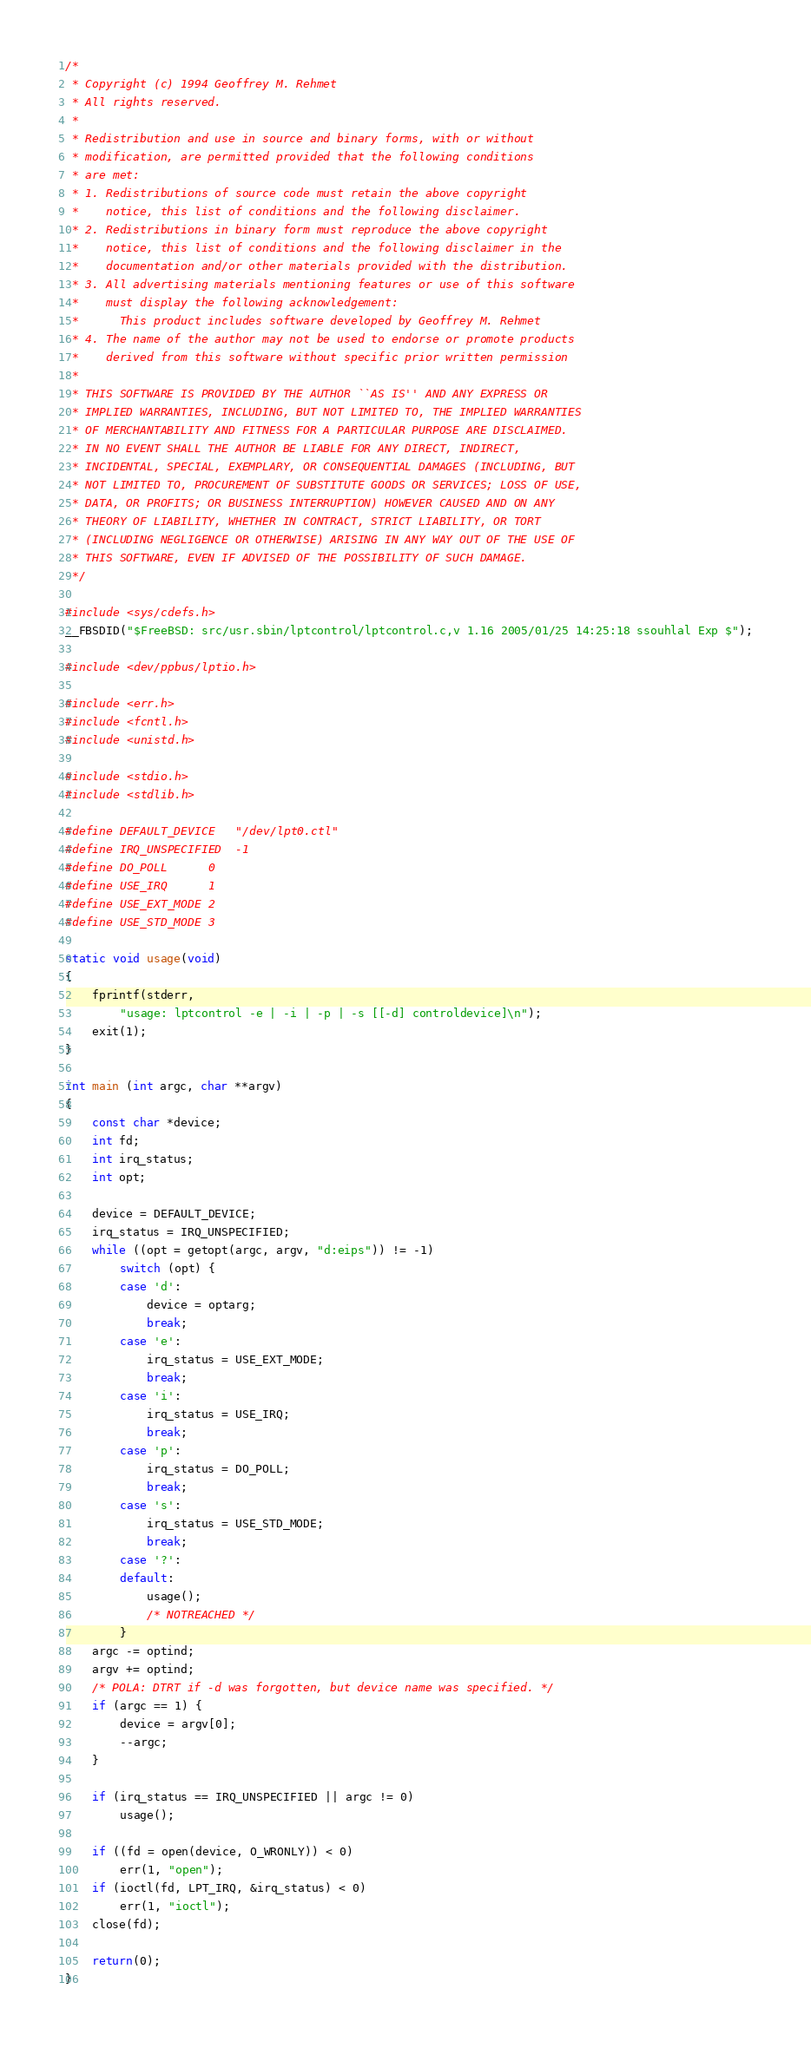<code> <loc_0><loc_0><loc_500><loc_500><_C_>/*
 * Copyright (c) 1994 Geoffrey M. Rehmet
 * All rights reserved.
 *
 * Redistribution and use in source and binary forms, with or without
 * modification, are permitted provided that the following conditions
 * are met:
 * 1. Redistributions of source code must retain the above copyright
 *    notice, this list of conditions and the following disclaimer.
 * 2. Redistributions in binary form must reproduce the above copyright
 *    notice, this list of conditions and the following disclaimer in the
 *    documentation and/or other materials provided with the distribution.
 * 3. All advertising materials mentioning features or use of this software
 *    must display the following acknowledgement:
 *      This product includes software developed by Geoffrey M. Rehmet
 * 4. The name of the author may not be used to endorse or promote products
 *    derived from this software without specific prior written permission
 *
 * THIS SOFTWARE IS PROVIDED BY THE AUTHOR ``AS IS'' AND ANY EXPRESS OR
 * IMPLIED WARRANTIES, INCLUDING, BUT NOT LIMITED TO, THE IMPLIED WARRANTIES
 * OF MERCHANTABILITY AND FITNESS FOR A PARTICULAR PURPOSE ARE DISCLAIMED.
 * IN NO EVENT SHALL THE AUTHOR BE LIABLE FOR ANY DIRECT, INDIRECT,
 * INCIDENTAL, SPECIAL, EXEMPLARY, OR CONSEQUENTIAL DAMAGES (INCLUDING, BUT
 * NOT LIMITED TO, PROCUREMENT OF SUBSTITUTE GOODS OR SERVICES; LOSS OF USE,
 * DATA, OR PROFITS; OR BUSINESS INTERRUPTION) HOWEVER CAUSED AND ON ANY
 * THEORY OF LIABILITY, WHETHER IN CONTRACT, STRICT LIABILITY, OR TORT
 * (INCLUDING NEGLIGENCE OR OTHERWISE) ARISING IN ANY WAY OUT OF THE USE OF
 * THIS SOFTWARE, EVEN IF ADVISED OF THE POSSIBILITY OF SUCH DAMAGE.
 */

#include <sys/cdefs.h>
__FBSDID("$FreeBSD: src/usr.sbin/lptcontrol/lptcontrol.c,v 1.16 2005/01/25 14:25:18 ssouhlal Exp $");

#include <dev/ppbus/lptio.h>

#include <err.h>
#include <fcntl.h>
#include <unistd.h>

#include <stdio.h>
#include <stdlib.h>

#define DEFAULT_DEVICE	"/dev/lpt0.ctl"
#define IRQ_UNSPECIFIED	-1
#define DO_POLL		0
#define USE_IRQ		1
#define USE_EXT_MODE	2
#define USE_STD_MODE	3

static void usage(void)
{
	fprintf(stderr,
		"usage: lptcontrol -e | -i | -p | -s [[-d] controldevice]\n");
	exit(1);
}

int main (int argc, char **argv)
{
	const char *device;
	int fd;
	int irq_status;
	int opt;

	device = DEFAULT_DEVICE;
	irq_status = IRQ_UNSPECIFIED;
	while ((opt = getopt(argc, argv, "d:eips")) != -1)
		switch (opt) {
		case 'd':
			device = optarg;
			break;
		case 'e':
			irq_status = USE_EXT_MODE;
			break;
		case 'i':
			irq_status = USE_IRQ;
			break;
		case 'p':
			irq_status = DO_POLL;
			break;
		case 's':
			irq_status = USE_STD_MODE;
			break;
		case '?':
		default:
			usage();
			/* NOTREACHED */
		}
	argc -= optind;
	argv += optind;
	/* POLA: DTRT if -d was forgotten, but device name was specified. */
	if (argc == 1) {
		device = argv[0];
		--argc;
	}

	if (irq_status == IRQ_UNSPECIFIED || argc != 0)
		usage();

	if ((fd = open(device, O_WRONLY)) < 0)
		err(1, "open");
	if (ioctl(fd, LPT_IRQ, &irq_status) < 0)
		err(1, "ioctl");
	close(fd);

	return(0);
}
</code> 